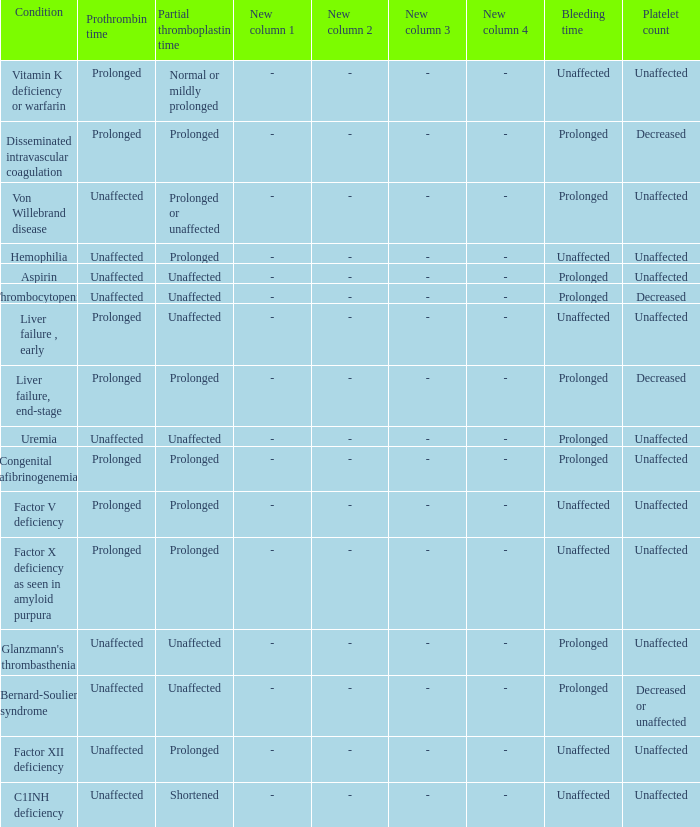Which Platelet count has a Condition of bernard-soulier syndrome? Decreased or unaffected. 